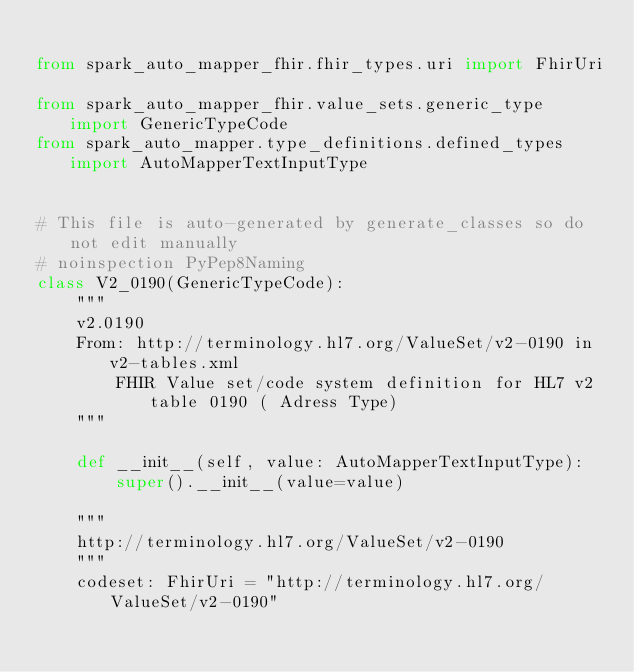<code> <loc_0><loc_0><loc_500><loc_500><_Python_>
from spark_auto_mapper_fhir.fhir_types.uri import FhirUri

from spark_auto_mapper_fhir.value_sets.generic_type import GenericTypeCode
from spark_auto_mapper.type_definitions.defined_types import AutoMapperTextInputType


# This file is auto-generated by generate_classes so do not edit manually
# noinspection PyPep8Naming
class V2_0190(GenericTypeCode):
    """
    v2.0190
    From: http://terminology.hl7.org/ValueSet/v2-0190 in v2-tables.xml
        FHIR Value set/code system definition for HL7 v2 table 0190 ( Adress Type)
    """

    def __init__(self, value: AutoMapperTextInputType):
        super().__init__(value=value)

    """
    http://terminology.hl7.org/ValueSet/v2-0190
    """
    codeset: FhirUri = "http://terminology.hl7.org/ValueSet/v2-0190"
</code> 